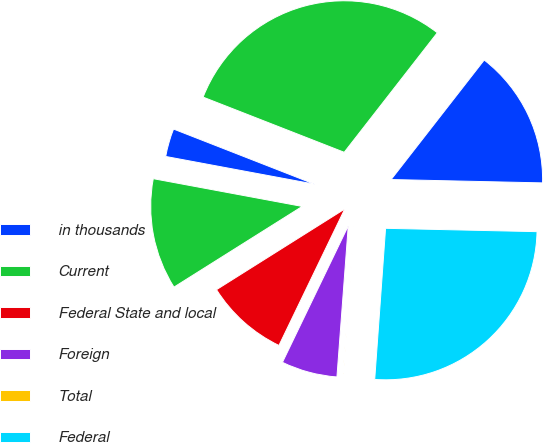Convert chart to OTSL. <chart><loc_0><loc_0><loc_500><loc_500><pie_chart><fcel>in thousands<fcel>Current<fcel>Federal State and local<fcel>Foreign<fcel>Total<fcel>Federal<fcel>State and local<fcel>Total expense (benefit)<nl><fcel>3.0%<fcel>11.87%<fcel>8.91%<fcel>5.96%<fcel>0.05%<fcel>25.79%<fcel>14.82%<fcel>29.6%<nl></chart> 